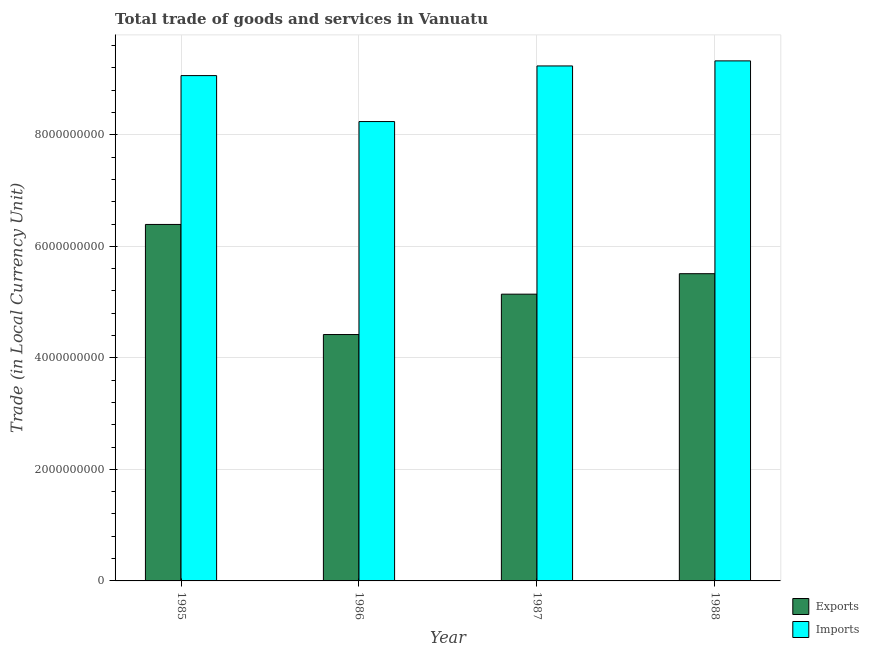Are the number of bars per tick equal to the number of legend labels?
Your response must be concise. Yes. What is the label of the 2nd group of bars from the left?
Your answer should be very brief. 1986. What is the export of goods and services in 1988?
Ensure brevity in your answer.  5.51e+09. Across all years, what is the maximum imports of goods and services?
Offer a terse response. 9.32e+09. Across all years, what is the minimum imports of goods and services?
Provide a succinct answer. 8.24e+09. In which year was the export of goods and services minimum?
Give a very brief answer. 1986. What is the total export of goods and services in the graph?
Your response must be concise. 2.15e+1. What is the difference between the imports of goods and services in 1985 and that in 1987?
Your response must be concise. -1.73e+08. What is the difference between the imports of goods and services in 1986 and the export of goods and services in 1987?
Offer a terse response. -9.97e+08. What is the average export of goods and services per year?
Your answer should be very brief. 5.37e+09. In how many years, is the imports of goods and services greater than 3200000000 LCU?
Offer a terse response. 4. What is the ratio of the export of goods and services in 1985 to that in 1988?
Ensure brevity in your answer.  1.16. What is the difference between the highest and the second highest imports of goods and services?
Ensure brevity in your answer.  9.10e+07. What is the difference between the highest and the lowest imports of goods and services?
Give a very brief answer. 1.09e+09. In how many years, is the imports of goods and services greater than the average imports of goods and services taken over all years?
Offer a very short reply. 3. What does the 2nd bar from the left in 1988 represents?
Your answer should be compact. Imports. What does the 2nd bar from the right in 1986 represents?
Your answer should be compact. Exports. Are all the bars in the graph horizontal?
Your response must be concise. No. How many years are there in the graph?
Keep it short and to the point. 4. What is the difference between two consecutive major ticks on the Y-axis?
Your response must be concise. 2.00e+09. Does the graph contain grids?
Provide a short and direct response. Yes. How are the legend labels stacked?
Keep it short and to the point. Vertical. What is the title of the graph?
Give a very brief answer. Total trade of goods and services in Vanuatu. Does "Gasoline" appear as one of the legend labels in the graph?
Provide a succinct answer. No. What is the label or title of the X-axis?
Give a very brief answer. Year. What is the label or title of the Y-axis?
Your answer should be compact. Trade (in Local Currency Unit). What is the Trade (in Local Currency Unit) in Exports in 1985?
Offer a very short reply. 6.39e+09. What is the Trade (in Local Currency Unit) in Imports in 1985?
Make the answer very short. 9.06e+09. What is the Trade (in Local Currency Unit) in Exports in 1986?
Provide a short and direct response. 4.42e+09. What is the Trade (in Local Currency Unit) of Imports in 1986?
Offer a terse response. 8.24e+09. What is the Trade (in Local Currency Unit) of Exports in 1987?
Your answer should be very brief. 5.14e+09. What is the Trade (in Local Currency Unit) in Imports in 1987?
Give a very brief answer. 9.23e+09. What is the Trade (in Local Currency Unit) of Exports in 1988?
Ensure brevity in your answer.  5.51e+09. What is the Trade (in Local Currency Unit) of Imports in 1988?
Provide a succinct answer. 9.32e+09. Across all years, what is the maximum Trade (in Local Currency Unit) in Exports?
Your answer should be compact. 6.39e+09. Across all years, what is the maximum Trade (in Local Currency Unit) in Imports?
Provide a short and direct response. 9.32e+09. Across all years, what is the minimum Trade (in Local Currency Unit) of Exports?
Your answer should be very brief. 4.42e+09. Across all years, what is the minimum Trade (in Local Currency Unit) of Imports?
Provide a succinct answer. 8.24e+09. What is the total Trade (in Local Currency Unit) of Exports in the graph?
Offer a very short reply. 2.15e+1. What is the total Trade (in Local Currency Unit) in Imports in the graph?
Keep it short and to the point. 3.59e+1. What is the difference between the Trade (in Local Currency Unit) in Exports in 1985 and that in 1986?
Your response must be concise. 1.97e+09. What is the difference between the Trade (in Local Currency Unit) of Imports in 1985 and that in 1986?
Offer a terse response. 8.24e+08. What is the difference between the Trade (in Local Currency Unit) of Exports in 1985 and that in 1987?
Keep it short and to the point. 1.25e+09. What is the difference between the Trade (in Local Currency Unit) of Imports in 1985 and that in 1987?
Provide a short and direct response. -1.73e+08. What is the difference between the Trade (in Local Currency Unit) of Exports in 1985 and that in 1988?
Ensure brevity in your answer.  8.83e+08. What is the difference between the Trade (in Local Currency Unit) in Imports in 1985 and that in 1988?
Your response must be concise. -2.64e+08. What is the difference between the Trade (in Local Currency Unit) in Exports in 1986 and that in 1987?
Offer a very short reply. -7.24e+08. What is the difference between the Trade (in Local Currency Unit) of Imports in 1986 and that in 1987?
Your response must be concise. -9.97e+08. What is the difference between the Trade (in Local Currency Unit) of Exports in 1986 and that in 1988?
Ensure brevity in your answer.  -1.09e+09. What is the difference between the Trade (in Local Currency Unit) of Imports in 1986 and that in 1988?
Give a very brief answer. -1.09e+09. What is the difference between the Trade (in Local Currency Unit) in Exports in 1987 and that in 1988?
Ensure brevity in your answer.  -3.67e+08. What is the difference between the Trade (in Local Currency Unit) of Imports in 1987 and that in 1988?
Ensure brevity in your answer.  -9.10e+07. What is the difference between the Trade (in Local Currency Unit) of Exports in 1985 and the Trade (in Local Currency Unit) of Imports in 1986?
Give a very brief answer. -1.84e+09. What is the difference between the Trade (in Local Currency Unit) in Exports in 1985 and the Trade (in Local Currency Unit) in Imports in 1987?
Ensure brevity in your answer.  -2.84e+09. What is the difference between the Trade (in Local Currency Unit) of Exports in 1985 and the Trade (in Local Currency Unit) of Imports in 1988?
Provide a short and direct response. -2.93e+09. What is the difference between the Trade (in Local Currency Unit) in Exports in 1986 and the Trade (in Local Currency Unit) in Imports in 1987?
Provide a short and direct response. -4.82e+09. What is the difference between the Trade (in Local Currency Unit) in Exports in 1986 and the Trade (in Local Currency Unit) in Imports in 1988?
Keep it short and to the point. -4.91e+09. What is the difference between the Trade (in Local Currency Unit) in Exports in 1987 and the Trade (in Local Currency Unit) in Imports in 1988?
Keep it short and to the point. -4.18e+09. What is the average Trade (in Local Currency Unit) in Exports per year?
Provide a succinct answer. 5.37e+09. What is the average Trade (in Local Currency Unit) in Imports per year?
Provide a succinct answer. 8.96e+09. In the year 1985, what is the difference between the Trade (in Local Currency Unit) of Exports and Trade (in Local Currency Unit) of Imports?
Make the answer very short. -2.67e+09. In the year 1986, what is the difference between the Trade (in Local Currency Unit) in Exports and Trade (in Local Currency Unit) in Imports?
Your answer should be very brief. -3.82e+09. In the year 1987, what is the difference between the Trade (in Local Currency Unit) of Exports and Trade (in Local Currency Unit) of Imports?
Your response must be concise. -4.09e+09. In the year 1988, what is the difference between the Trade (in Local Currency Unit) of Exports and Trade (in Local Currency Unit) of Imports?
Ensure brevity in your answer.  -3.82e+09. What is the ratio of the Trade (in Local Currency Unit) of Exports in 1985 to that in 1986?
Make the answer very short. 1.45. What is the ratio of the Trade (in Local Currency Unit) of Imports in 1985 to that in 1986?
Provide a succinct answer. 1.1. What is the ratio of the Trade (in Local Currency Unit) in Exports in 1985 to that in 1987?
Your answer should be very brief. 1.24. What is the ratio of the Trade (in Local Currency Unit) of Imports in 1985 to that in 1987?
Keep it short and to the point. 0.98. What is the ratio of the Trade (in Local Currency Unit) in Exports in 1985 to that in 1988?
Give a very brief answer. 1.16. What is the ratio of the Trade (in Local Currency Unit) of Imports in 1985 to that in 1988?
Your answer should be compact. 0.97. What is the ratio of the Trade (in Local Currency Unit) in Exports in 1986 to that in 1987?
Ensure brevity in your answer.  0.86. What is the ratio of the Trade (in Local Currency Unit) in Imports in 1986 to that in 1987?
Ensure brevity in your answer.  0.89. What is the ratio of the Trade (in Local Currency Unit) in Exports in 1986 to that in 1988?
Your answer should be very brief. 0.8. What is the ratio of the Trade (in Local Currency Unit) of Imports in 1986 to that in 1988?
Make the answer very short. 0.88. What is the ratio of the Trade (in Local Currency Unit) of Exports in 1987 to that in 1988?
Your response must be concise. 0.93. What is the ratio of the Trade (in Local Currency Unit) of Imports in 1987 to that in 1988?
Ensure brevity in your answer.  0.99. What is the difference between the highest and the second highest Trade (in Local Currency Unit) of Exports?
Offer a very short reply. 8.83e+08. What is the difference between the highest and the second highest Trade (in Local Currency Unit) in Imports?
Provide a succinct answer. 9.10e+07. What is the difference between the highest and the lowest Trade (in Local Currency Unit) of Exports?
Make the answer very short. 1.97e+09. What is the difference between the highest and the lowest Trade (in Local Currency Unit) of Imports?
Provide a short and direct response. 1.09e+09. 